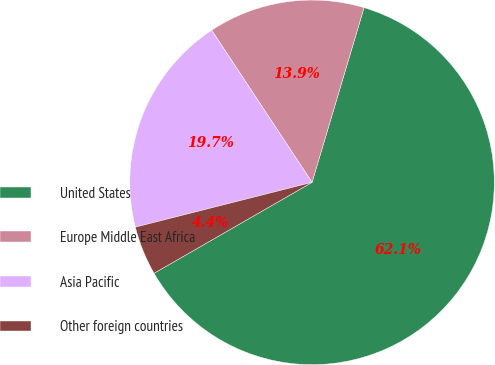<chart> <loc_0><loc_0><loc_500><loc_500><pie_chart><fcel>United States<fcel>Europe Middle East Africa<fcel>Asia Pacific<fcel>Other foreign countries<nl><fcel>62.09%<fcel>13.89%<fcel>19.67%<fcel>4.36%<nl></chart> 